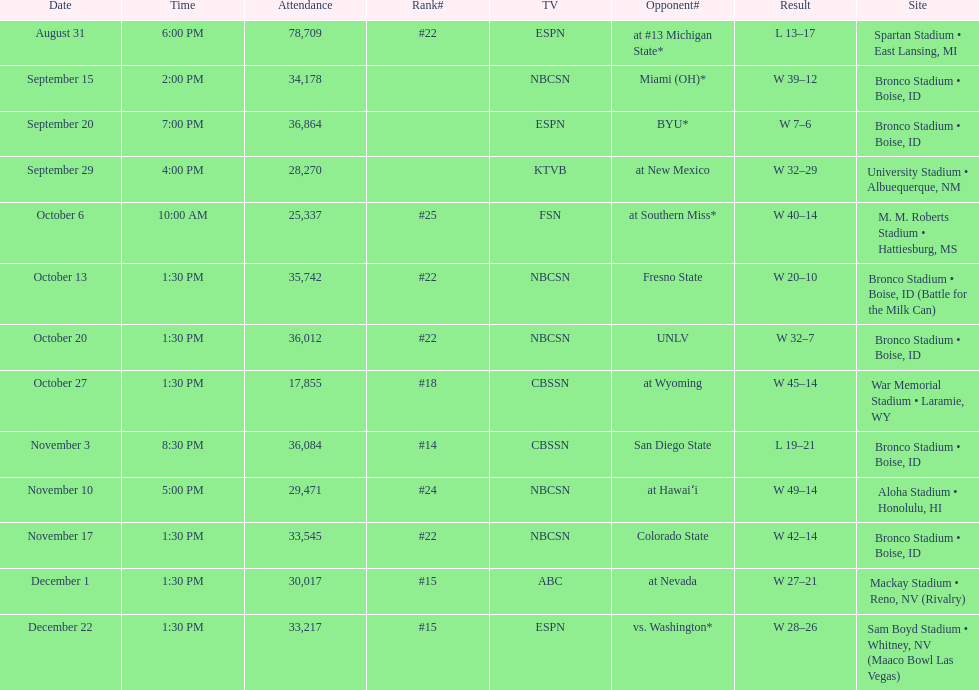What was there top ranked position of the season? #14. 